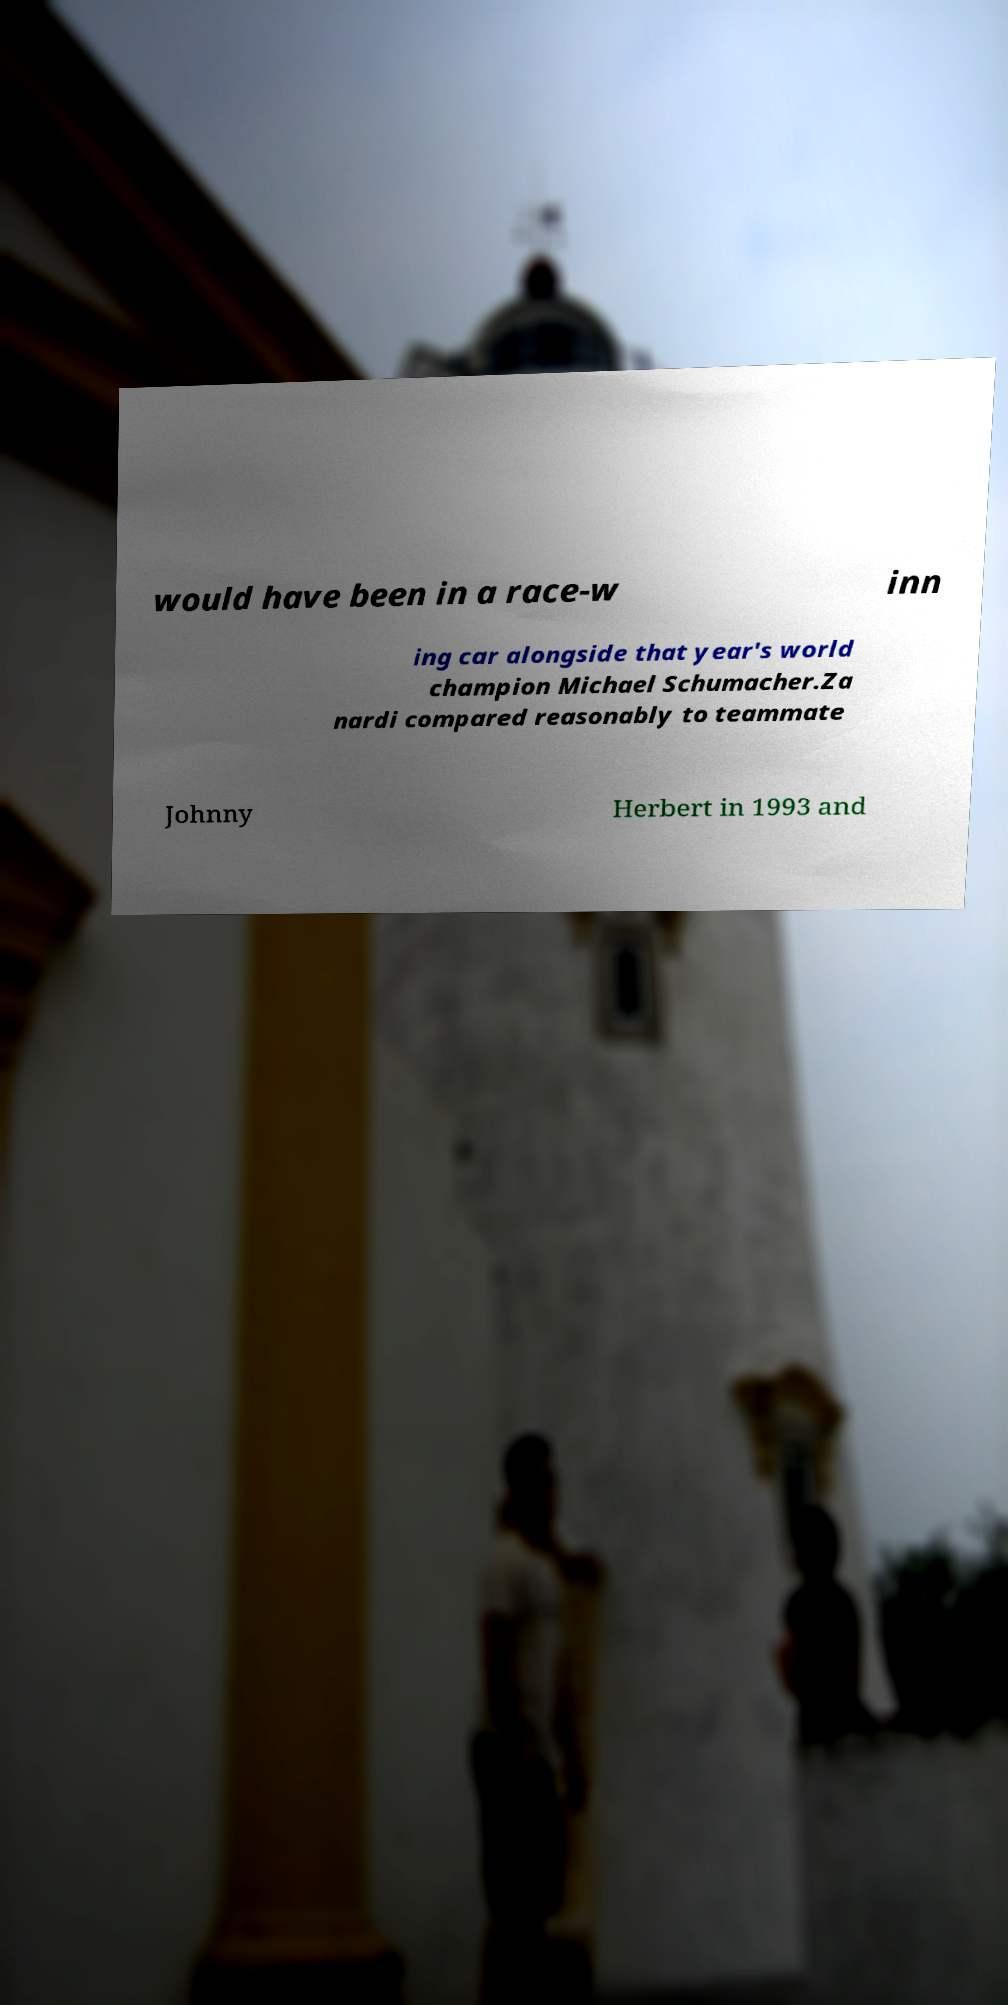Please identify and transcribe the text found in this image. would have been in a race-w inn ing car alongside that year's world champion Michael Schumacher.Za nardi compared reasonably to teammate Johnny Herbert in 1993 and 